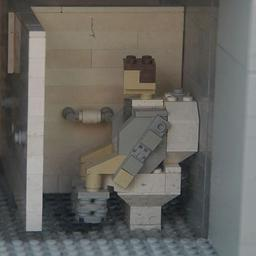What artistic techniques are noticeable in this Lego sculpture that contribute to its overall impact? The sculpture employs a meticulous attention to detail and a realistic palette that mirrors the actual environment it represents. The use of monochrome colors enhances the focus on the subject matter without distraction, while the compact composition in a small space intensifies the personal feel of the scenario, adding depth to the artistic expression. 